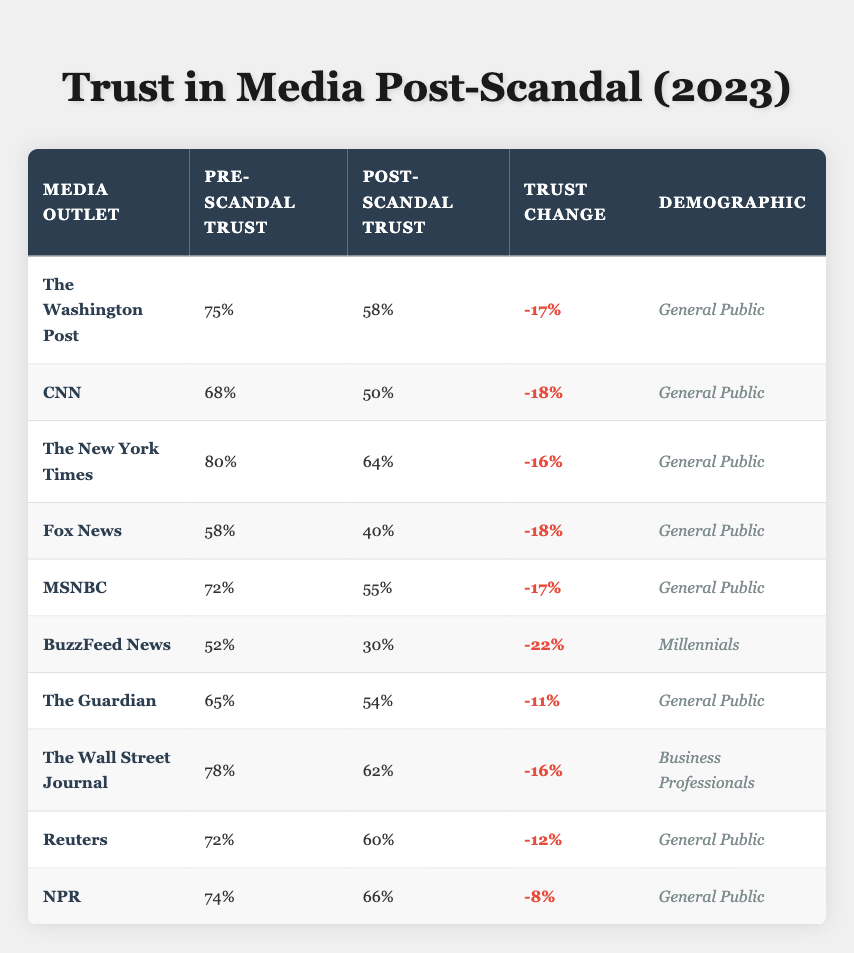What is the post-scandal trust percentage for CNN? The table shows that CNN's post-scandal trust percentage is listed as 50%.
Answer: 50% Which media outlet had the highest pre-scandal trust? The pre-scandal trust for The New York Times was the highest at 80%.
Answer: The New York Times What was the trust change for The Wall Street Journal? The trust change for The Wall Street Journal is stated as -16%.
Answer: -16% Is the post-scandal trust for NPR higher than that of The Guardian? NPR's post-scandal trust (66%) is indeed higher than The Guardian's (54%).
Answer: Yes What is the average pre-scandal trust percentage for the media outlets listed? The pre-scandal trust values for all outlets add up to 725. There are 10 outlets, so the average is 725 / 10 = 72.5%.
Answer: 72.5% Which demographic saw the largest decrease in trust with BuzzFeed News? The table shows a -22% change in trust for BuzzFeed News among Millennials, which is the largest decrease listed.
Answer: Millennials What percentage of post-scandal trust does NPR represent compared to the lowest post-scandal trust value? The lowest post-scandal trust is 30% (BuzzFeed News). NPR's post-scandal trust (66%) is 36% higher than this lowest value.
Answer: 36% How many outlets experienced a trust change of -18%? Both CNN and Fox News had trust changes of -18%, totaling 2 outlets.
Answer: 2 outlets What is the difference in post-scandal trust between The New York Times and MSNBC? The New York Times post-scandal trust is 64%, while MSNBC is 55%. The difference is 64% - 55% = 9%.
Answer: 9% Did any media outlet show an increase in trust after the scandal? The table indicates that every outlet reported a decrease in trust after the scandal, so no outlet showed an increase.
Answer: No 